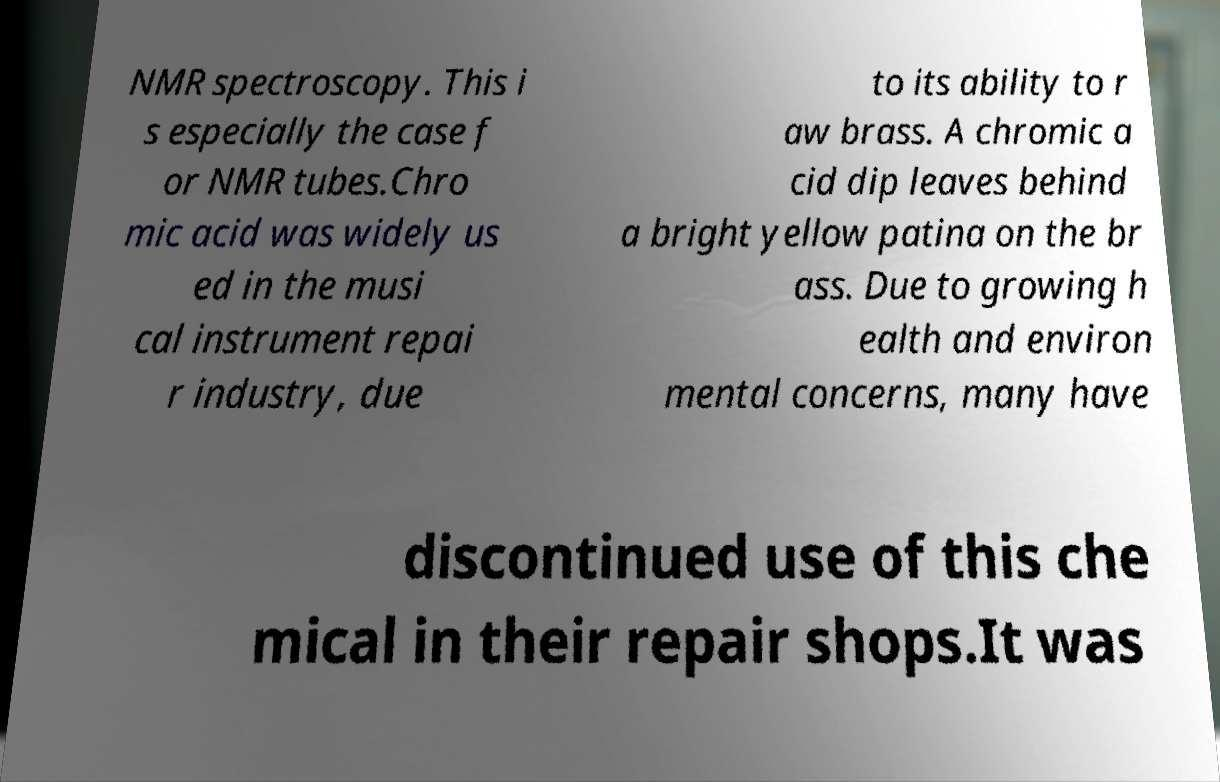I need the written content from this picture converted into text. Can you do that? NMR spectroscopy. This i s especially the case f or NMR tubes.Chro mic acid was widely us ed in the musi cal instrument repai r industry, due to its ability to r aw brass. A chromic a cid dip leaves behind a bright yellow patina on the br ass. Due to growing h ealth and environ mental concerns, many have discontinued use of this che mical in their repair shops.It was 